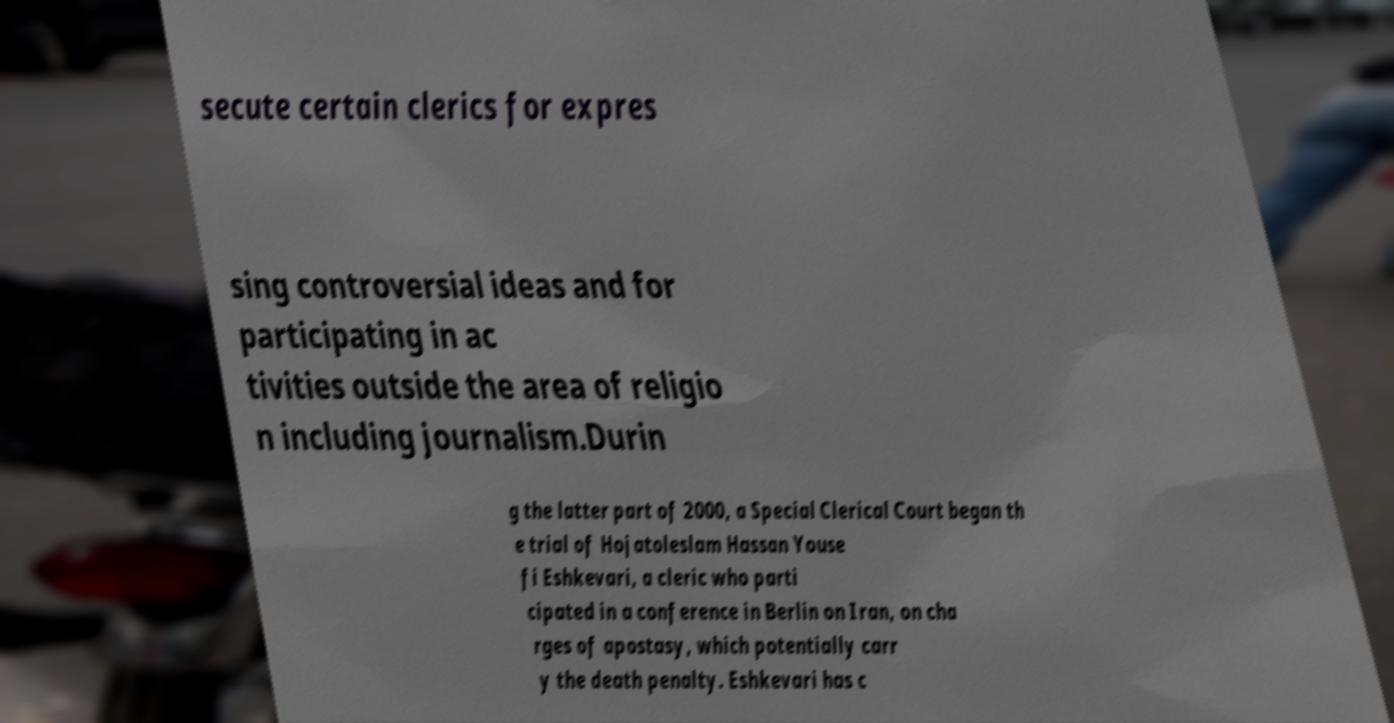Can you read and provide the text displayed in the image?This photo seems to have some interesting text. Can you extract and type it out for me? secute certain clerics for expres sing controversial ideas and for participating in ac tivities outside the area of religio n including journalism.Durin g the latter part of 2000, a Special Clerical Court began th e trial of Hojatoleslam Hassan Youse fi Eshkevari, a cleric who parti cipated in a conference in Berlin on Iran, on cha rges of apostasy, which potentially carr y the death penalty. Eshkevari has c 